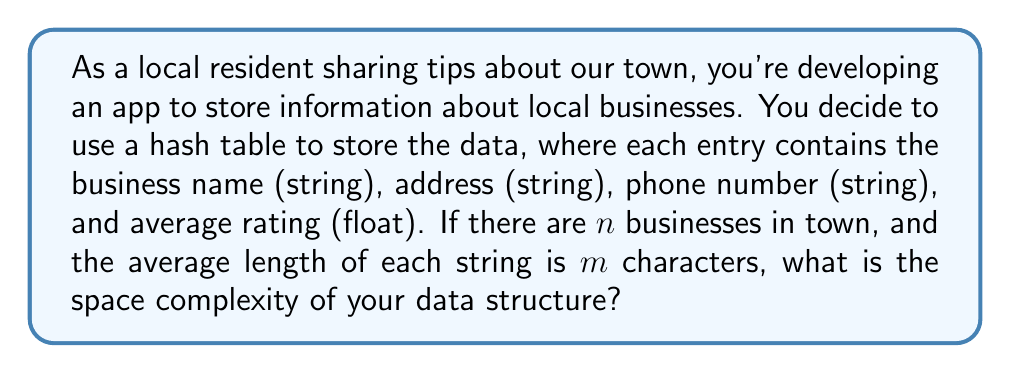What is the answer to this math problem? Let's break this down step-by-step:

1) First, we need to consider the space required for each business entry:
   - Business name: $O(m)$ space
   - Address: $O(m)$ space
   - Phone number: $O(m)$ space
   - Average rating: $O(1)$ space (constant for a float)

2) The total space for one business entry is therefore $O(3m + 1) = O(m)$.

3) We have $n$ businesses, so the space required for all business data is $O(nm)$.

4) However, we're using a hash table to store this information. Hash tables typically have a load factor $\alpha$ (usually around 0.75) to maintain efficiency. This means the actual size of the hash table will be larger than $n$ by a constant factor.

5) The space complexity of a hash table with $n$ elements is $O(n/\alpha)$, which simplifies to $O(n)$ since $\alpha$ is a constant.

6) Combining the space for the business data and the hash table structure, we get:
   $O(nm) + O(n) = O(nm)$

Therefore, the overall space complexity is $O(nm)$.
Answer: $O(nm)$, where $n$ is the number of businesses and $m$ is the average length of each string. 